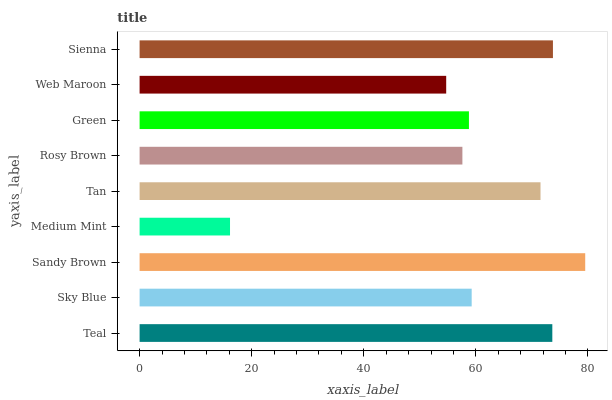Is Medium Mint the minimum?
Answer yes or no. Yes. Is Sandy Brown the maximum?
Answer yes or no. Yes. Is Sky Blue the minimum?
Answer yes or no. No. Is Sky Blue the maximum?
Answer yes or no. No. Is Teal greater than Sky Blue?
Answer yes or no. Yes. Is Sky Blue less than Teal?
Answer yes or no. Yes. Is Sky Blue greater than Teal?
Answer yes or no. No. Is Teal less than Sky Blue?
Answer yes or no. No. Is Sky Blue the high median?
Answer yes or no. Yes. Is Sky Blue the low median?
Answer yes or no. Yes. Is Sandy Brown the high median?
Answer yes or no. No. Is Web Maroon the low median?
Answer yes or no. No. 